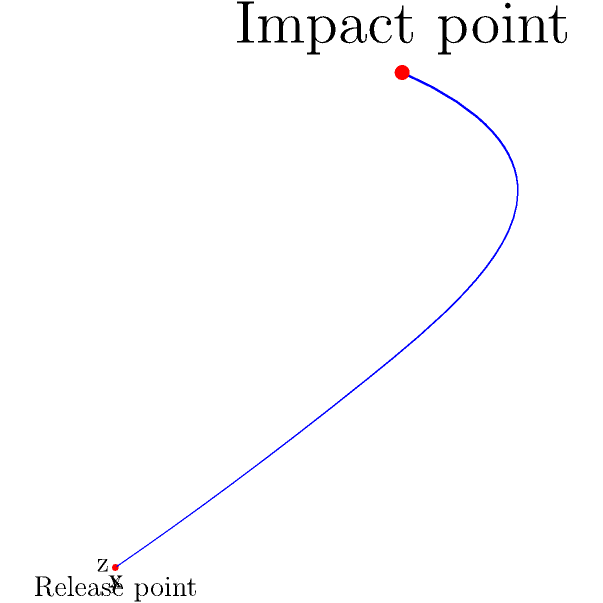Rangana Herath delivers a ball that follows the trajectory shown in the 3D coordinate system above. The release point is at (0,0,0) and the impact point is at (3,3,6). Calculate the total distance traveled by the ball in meters, assuming each unit in the coordinate system represents 1 meter. To calculate the total distance traveled by the ball, we need to find the straight-line distance between the release point and the impact point in 3D space. We can use the distance formula in three dimensions:

$$d = \sqrt{(x_2-x_1)^2 + (y_2-y_1)^2 + (z_2-z_1)^2}$$

Given:
- Release point: $(x_1, y_1, z_1) = (0, 0, 0)$
- Impact point: $(x_2, y_2, z_2) = (3, 3, 6)$

Step 1: Substitute the coordinates into the formula:
$$d = \sqrt{(3-0)^2 + (3-0)^2 + (6-0)^2}$$

Step 2: Simplify:
$$d = \sqrt{3^2 + 3^2 + 6^2}$$

Step 3: Calculate the squares:
$$d = \sqrt{9 + 9 + 36}$$

Step 4: Sum the values under the square root:
$$d = \sqrt{54}$$

Step 5: Simplify the square root:
$$d = 3\sqrt{6}$$

Since each unit represents 1 meter, the total distance traveled by the ball is $3\sqrt{6}$ meters.
Answer: $3\sqrt{6}$ meters 